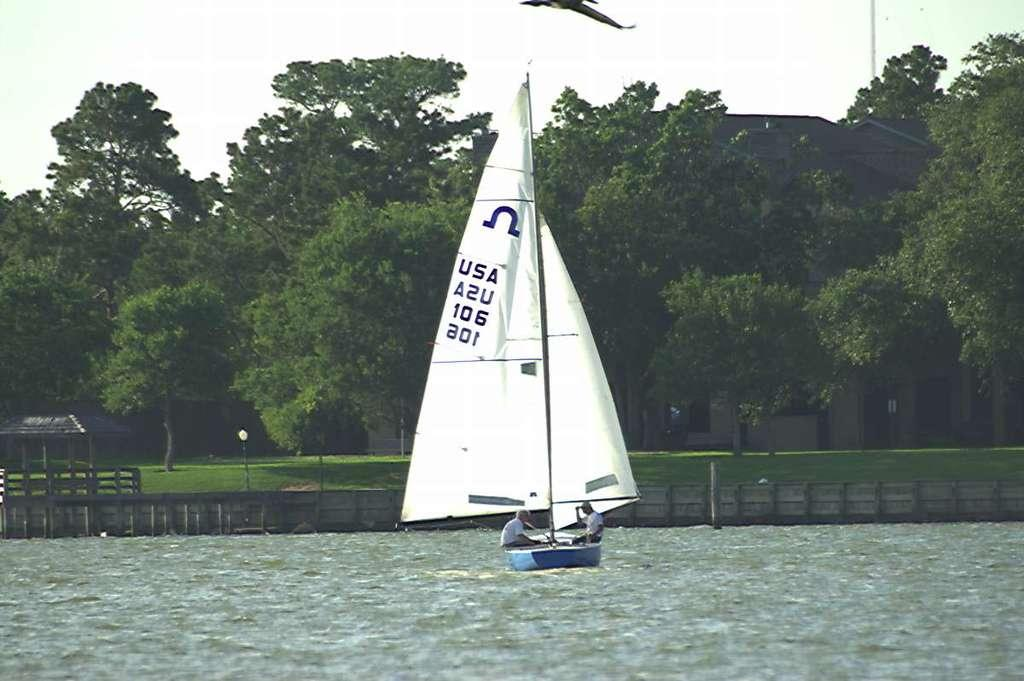What is located above the water in the image? There is a boat above the water in the image. What can be seen in the background of the image? The sky and trees are visible in the background of the image. What type of vegetation is present in the image? There is grass in the image. How many people are in the image? There are two people in the image. What type of pear is being used as a prop by one of the people in the image? There is no pear present in the image; it only features a boat, the sky, trees, grass, and two people. 